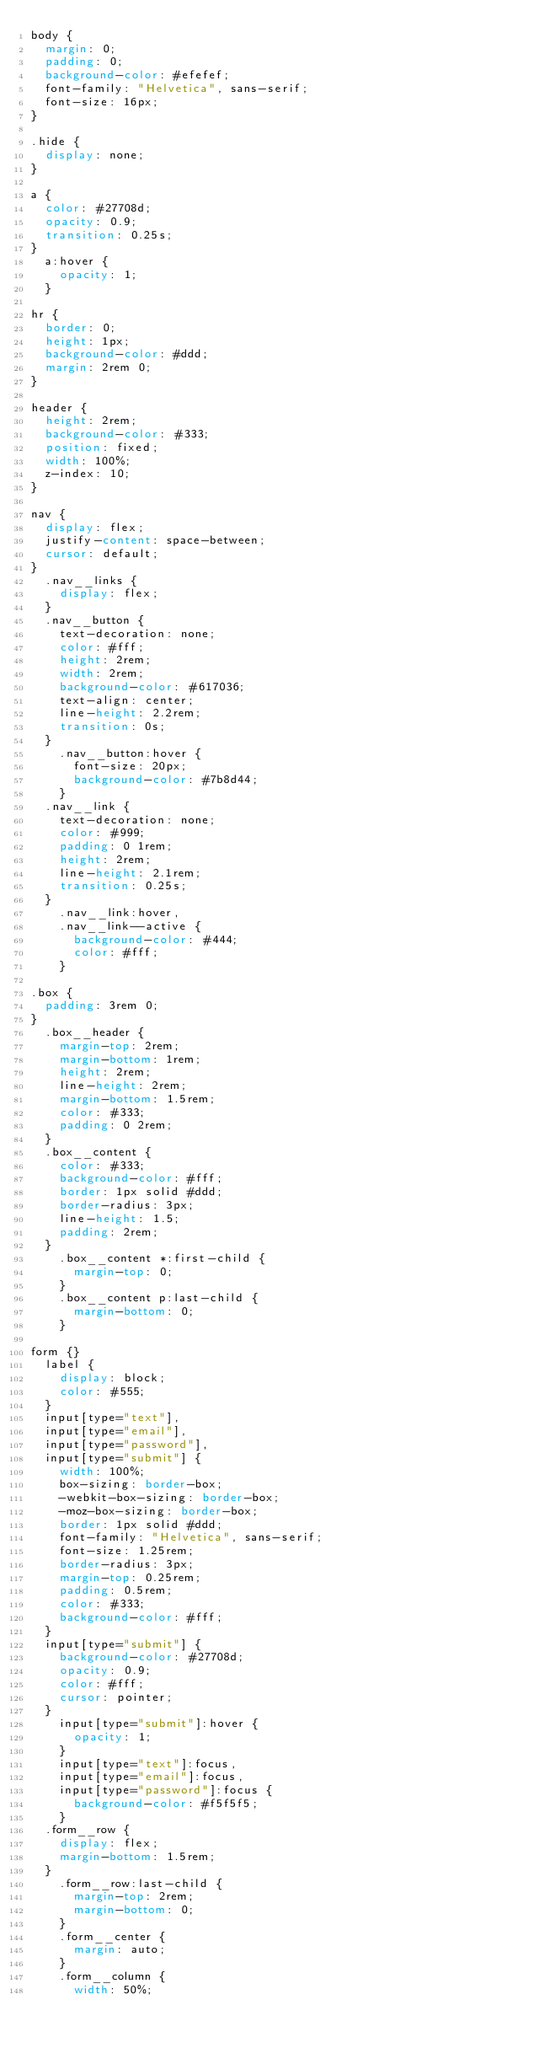<code> <loc_0><loc_0><loc_500><loc_500><_CSS_>body {
  margin: 0;
  padding: 0;
  background-color: #efefef;
  font-family: "Helvetica", sans-serif;
  font-size: 16px;
}

.hide {
  display: none;
}

a {
  color: #27708d;
  opacity: 0.9;
  transition: 0.25s;
}
  a:hover {
    opacity: 1;
  }

hr {
  border: 0;
  height: 1px;
  background-color: #ddd;
  margin: 2rem 0;
}

header {
  height: 2rem;
  background-color: #333;
  position: fixed;
  width: 100%;
  z-index: 10;
}

nav {
  display: flex;
  justify-content: space-between;
  cursor: default;
}
  .nav__links {
    display: flex;
  }
  .nav__button {
    text-decoration: none;
    color: #fff;
    height: 2rem;
    width: 2rem;
    background-color: #617036;
    text-align: center;
    line-height: 2.2rem;
    transition: 0s;
  }
    .nav__button:hover {
      font-size: 20px;
      background-color: #7b8d44;
    }
  .nav__link {
    text-decoration: none;
    color: #999;
    padding: 0 1rem; 
    height: 2rem;
    line-height: 2.1rem;
    transition: 0.25s;
  }
    .nav__link:hover,
    .nav__link--active {
      background-color: #444;
      color: #fff;
    }

.box {
  padding: 3rem 0; 
}
  .box__header {
    margin-top: 2rem;
    margin-bottom: 1rem; 
    height: 2rem;
    line-height: 2rem;
    margin-bottom: 1.5rem;
    color: #333;
    padding: 0 2rem; 
  }
  .box__content {
    color: #333;
    background-color: #fff;
    border: 1px solid #ddd;
    border-radius: 3px;
    line-height: 1.5;
    padding: 2rem;
  }
    .box__content *:first-child {
      margin-top: 0;
    }
    .box__content p:last-child {
      margin-bottom: 0;
    }

form {}
  label {
    display: block;
    color: #555;
  }
  input[type="text"],
  input[type="email"],
  input[type="password"],
  input[type="submit"] {
    width: 100%;
    box-sizing: border-box;
    -webkit-box-sizing: border-box;
    -moz-box-sizing: border-box;
    border: 1px solid #ddd;
    font-family: "Helvetica", sans-serif;
    font-size: 1.25rem;
    border-radius: 3px;
    margin-top: 0.25rem;
    padding: 0.5rem;
    color: #333;
    background-color: #fff; 
  }
  input[type="submit"] {
    background-color: #27708d;
    opacity: 0.9;
    color: #fff;
    cursor: pointer;
  } 
    input[type="submit"]:hover {
      opacity: 1; 
    }
    input[type="text"]:focus,
    input[type="email"]:focus,
    input[type="password"]:focus {
      background-color: #f5f5f5;
    }
  .form__row {
    display: flex;
    margin-bottom: 1.5rem;
  }
    .form__row:last-child {
      margin-top: 2rem;
      margin-bottom: 0;
    }
    .form__center {
      margin: auto; 
    }
    .form__column {
      width: 50%;</code> 